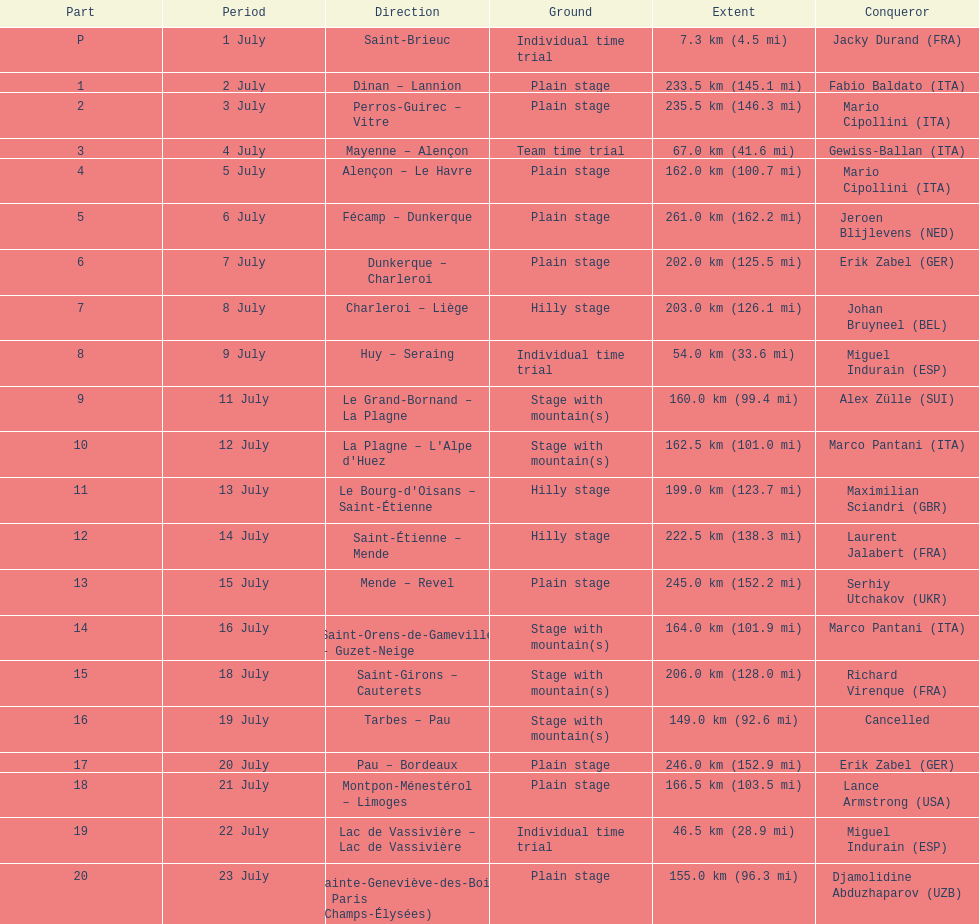Which country had more stage-winners than any other country? Italy. 